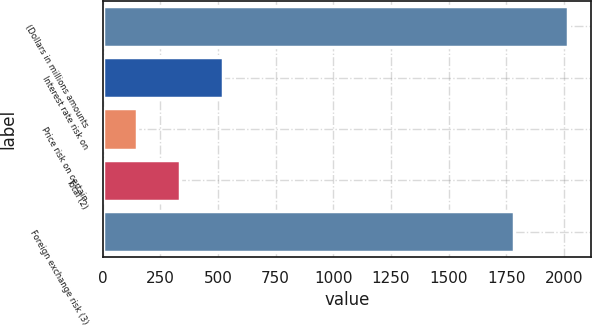Convert chart to OTSL. <chart><loc_0><loc_0><loc_500><loc_500><bar_chart><fcel>(Dollars in millions amounts<fcel>Interest rate risk on<fcel>Price risk on certain<fcel>Total (2)<fcel>Foreign exchange risk (3)<nl><fcel>2017<fcel>521.8<fcel>148<fcel>334.9<fcel>1782<nl></chart> 